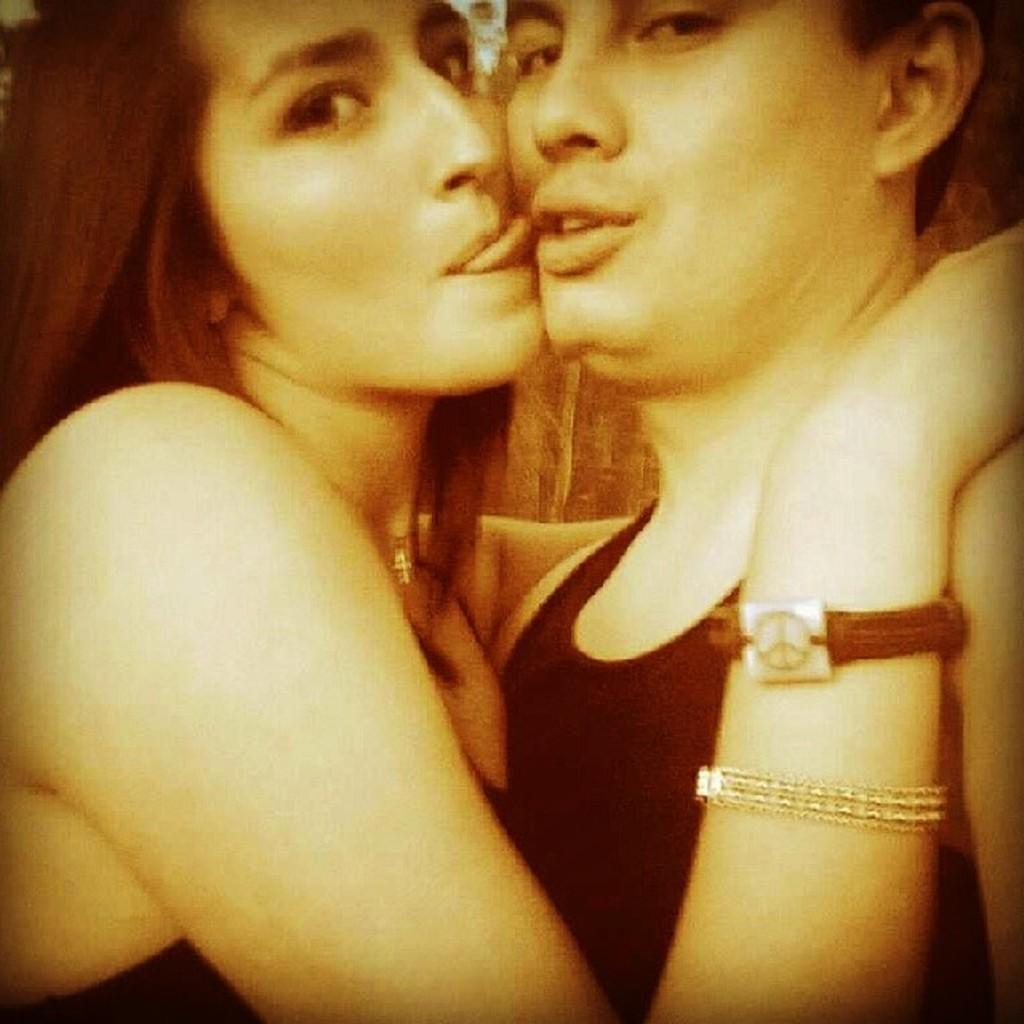How many people are present in the image? There are two people in the image. What are the two people doing in the image? The two people are taking pictures. What type of humor can be seen in the image? There is no humor present in the image; it simply shows two people taking pictures. 